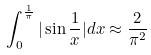<formula> <loc_0><loc_0><loc_500><loc_500>\int _ { 0 } ^ { \frac { 1 } { \pi } } | \sin \frac { 1 } { x } | d x \approx \frac { 2 } { \pi ^ { 2 } }</formula> 